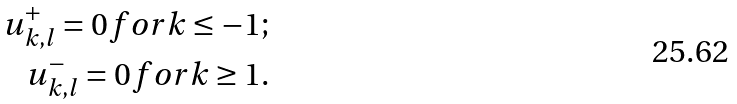<formula> <loc_0><loc_0><loc_500><loc_500>u ^ { + } _ { k , l } = 0 f o r k \leq - 1 ; \\ u ^ { - } _ { k , l } = 0 f o r k \geq 1 .</formula> 